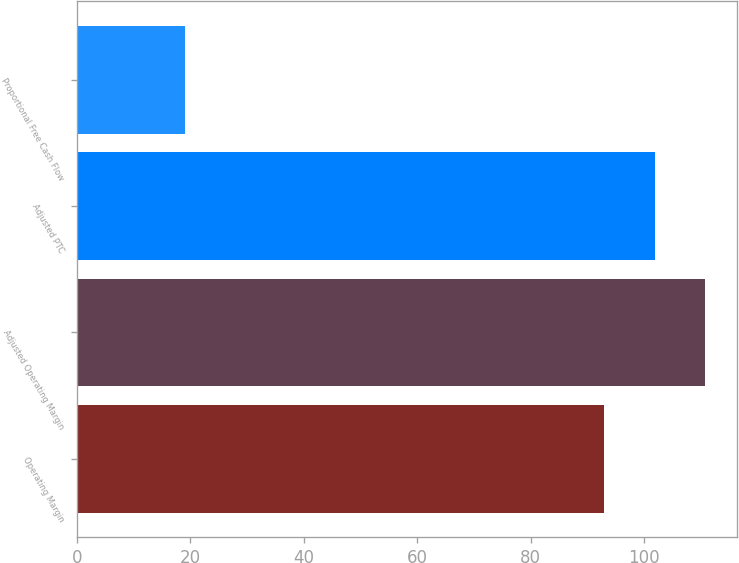Convert chart to OTSL. <chart><loc_0><loc_0><loc_500><loc_500><bar_chart><fcel>Operating Margin<fcel>Adjusted Operating Margin<fcel>Adjusted PTC<fcel>Proportional Free Cash Flow<nl><fcel>93<fcel>110.8<fcel>101.9<fcel>19<nl></chart> 